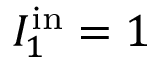Convert formula to latex. <formula><loc_0><loc_0><loc_500><loc_500>I _ { 1 } ^ { i n } = 1</formula> 